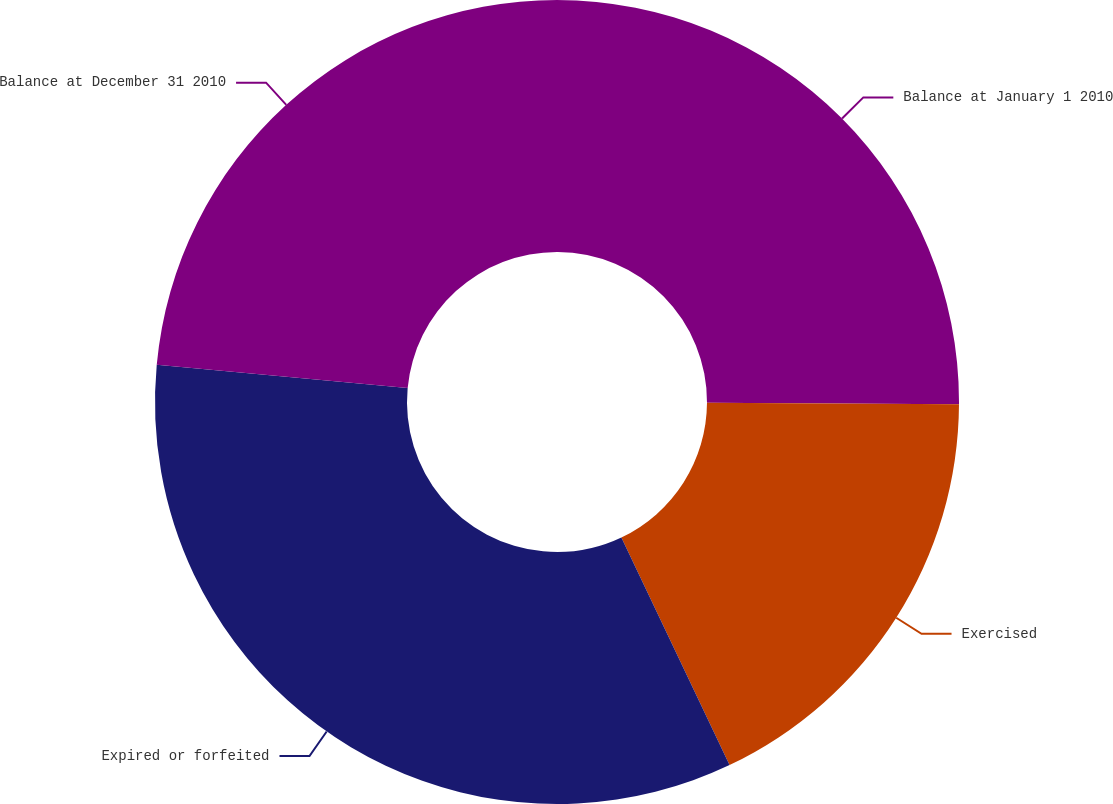Convert chart to OTSL. <chart><loc_0><loc_0><loc_500><loc_500><pie_chart><fcel>Balance at January 1 2010<fcel>Exercised<fcel>Expired or forfeited<fcel>Balance at December 31 2010<nl><fcel>25.09%<fcel>17.85%<fcel>33.54%<fcel>23.52%<nl></chart> 